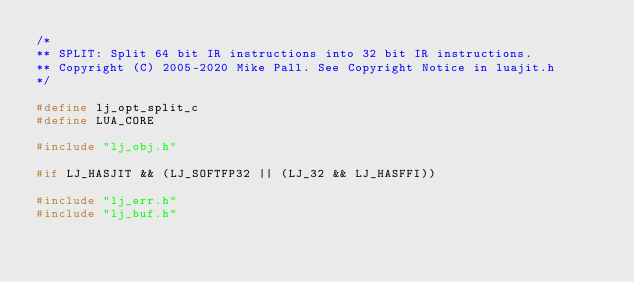<code> <loc_0><loc_0><loc_500><loc_500><_C_>/*
** SPLIT: Split 64 bit IR instructions into 32 bit IR instructions.
** Copyright (C) 2005-2020 Mike Pall. See Copyright Notice in luajit.h
*/

#define lj_opt_split_c
#define LUA_CORE

#include "lj_obj.h"

#if LJ_HASJIT && (LJ_SOFTFP32 || (LJ_32 && LJ_HASFFI))

#include "lj_err.h"
#include "lj_buf.h"</code> 